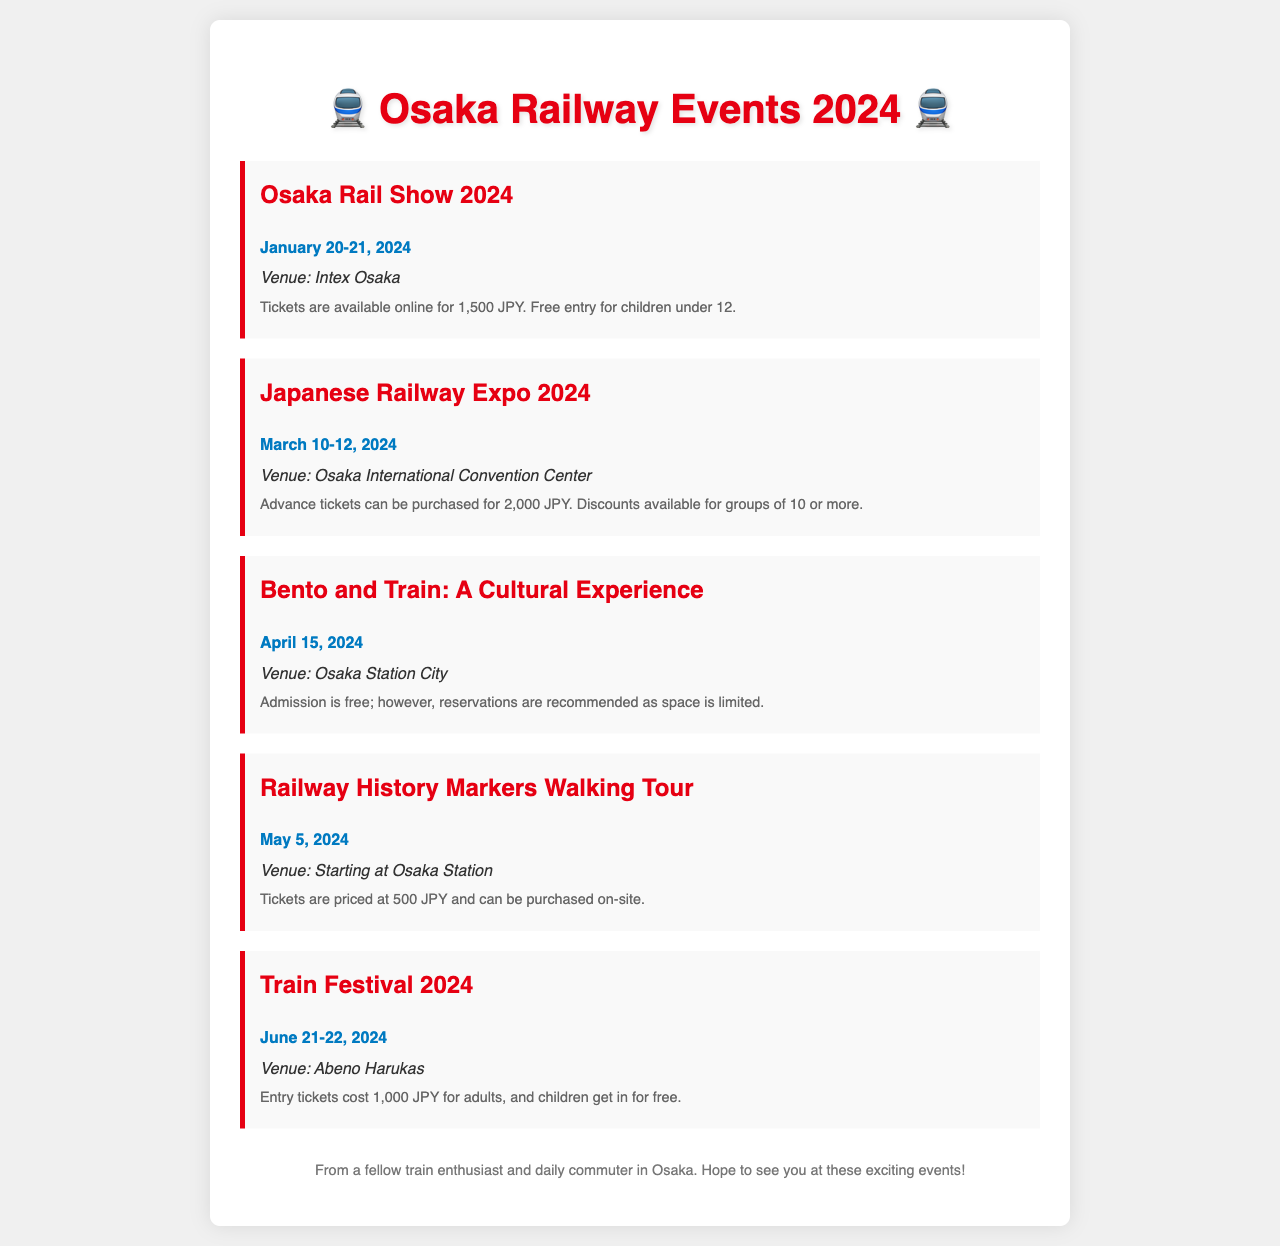What is the date of the Osaka Rail Show 2024? The date for the Osaka Rail Show 2024 is listed in the document as January 20-21, 2024.
Answer: January 20-21, 2024 Where will the Japanese Railway Expo 2024 be held? The venue for the Japanese Railway Expo 2024 is mentioned as the Osaka International Convention Center.
Answer: Osaka International Convention Center What is the ticket price for the Train Festival 2024? The document states that entry tickets for the Train Festival 2024 cost 1,000 JPY for adults.
Answer: 1,000 JPY How many days does the Osaka Rail Show 2024 last? The Osaka Rail Show 2024 takes place over two days, as indicated by the dates provided in the document.
Answer: Two days Is admission free for the Bento and Train event? The document informs that admission for the Bento and Train event is free but recommends reservations due to limited space.
Answer: Yes What is the starting location for the Railway History Markers Walking Tour? The document specifies that the Railway History Markers Walking Tour begins at Osaka Station.
Answer: Osaka Station How much is the discount for group tickets for the Japanese Railway Expo 2024? The document indicates that there are discounts available for groups of 10 or more, though it does not specify the amount.
Answer: Not specified What kind of experience is the Bento and Train event described as? The event is described as a cultural experience in the document, highlighting its activity theme.
Answer: A cultural experience 